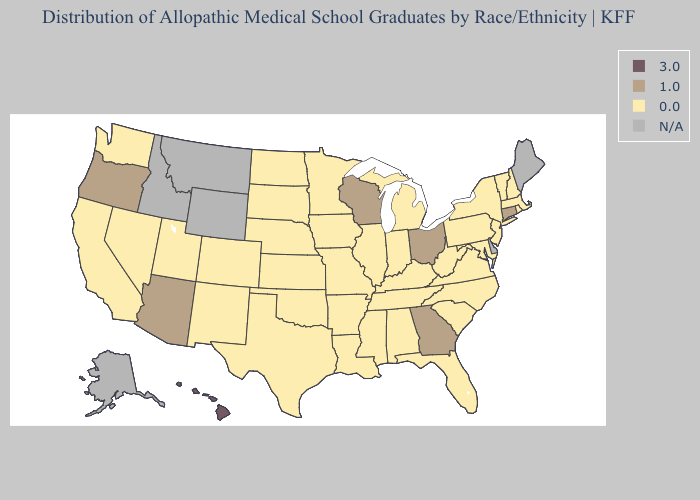Which states have the lowest value in the South?
Be succinct. Alabama, Arkansas, Florida, Kentucky, Louisiana, Maryland, Mississippi, North Carolina, Oklahoma, South Carolina, Tennessee, Texas, Virginia, West Virginia. Does Oklahoma have the highest value in the South?
Give a very brief answer. No. Among the states that border North Carolina , which have the lowest value?
Answer briefly. South Carolina, Tennessee, Virginia. Which states have the highest value in the USA?
Be succinct. Hawaii. Name the states that have a value in the range N/A?
Keep it brief. Alaska, Delaware, Idaho, Maine, Montana, Wyoming. Name the states that have a value in the range 0.0?
Concise answer only. Alabama, Arkansas, California, Colorado, Florida, Illinois, Indiana, Iowa, Kansas, Kentucky, Louisiana, Maryland, Massachusetts, Michigan, Minnesota, Mississippi, Missouri, Nebraska, Nevada, New Hampshire, New Jersey, New Mexico, New York, North Carolina, North Dakota, Oklahoma, Pennsylvania, Rhode Island, South Carolina, South Dakota, Tennessee, Texas, Utah, Vermont, Virginia, Washington, West Virginia. Name the states that have a value in the range 1.0?
Give a very brief answer. Arizona, Connecticut, Georgia, Ohio, Oregon, Wisconsin. Name the states that have a value in the range 1.0?
Answer briefly. Arizona, Connecticut, Georgia, Ohio, Oregon, Wisconsin. Which states have the lowest value in the USA?
Give a very brief answer. Alabama, Arkansas, California, Colorado, Florida, Illinois, Indiana, Iowa, Kansas, Kentucky, Louisiana, Maryland, Massachusetts, Michigan, Minnesota, Mississippi, Missouri, Nebraska, Nevada, New Hampshire, New Jersey, New Mexico, New York, North Carolina, North Dakota, Oklahoma, Pennsylvania, Rhode Island, South Carolina, South Dakota, Tennessee, Texas, Utah, Vermont, Virginia, Washington, West Virginia. What is the value of Texas?
Concise answer only. 0.0. What is the value of Florida?
Be succinct. 0.0. Name the states that have a value in the range 3.0?
Concise answer only. Hawaii. How many symbols are there in the legend?
Concise answer only. 4. Among the states that border New Mexico , which have the highest value?
Give a very brief answer. Arizona. 